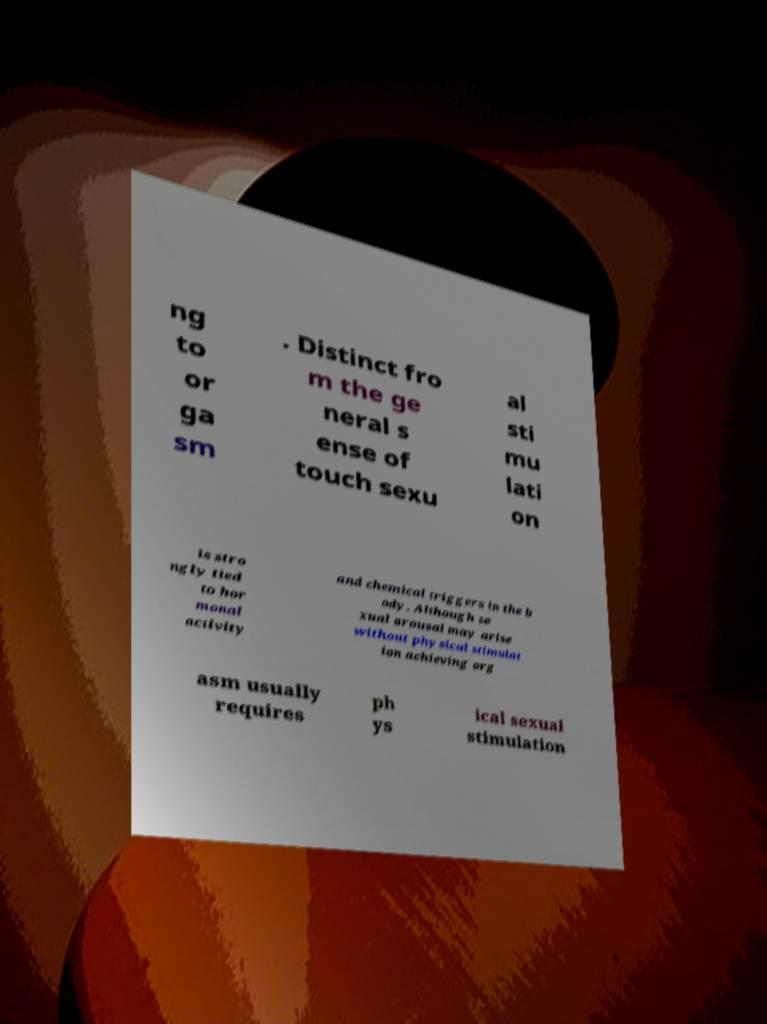Could you assist in decoding the text presented in this image and type it out clearly? ng to or ga sm . Distinct fro m the ge neral s ense of touch sexu al sti mu lati on is stro ngly tied to hor monal activity and chemical triggers in the b ody. Although se xual arousal may arise without physical stimulat ion achieving org asm usually requires ph ys ical sexual stimulation 